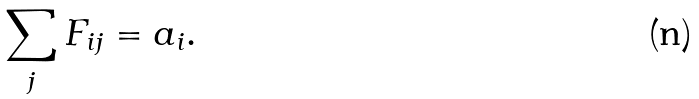<formula> <loc_0><loc_0><loc_500><loc_500>\sum _ { j } F _ { i j } = a _ { i } .</formula> 